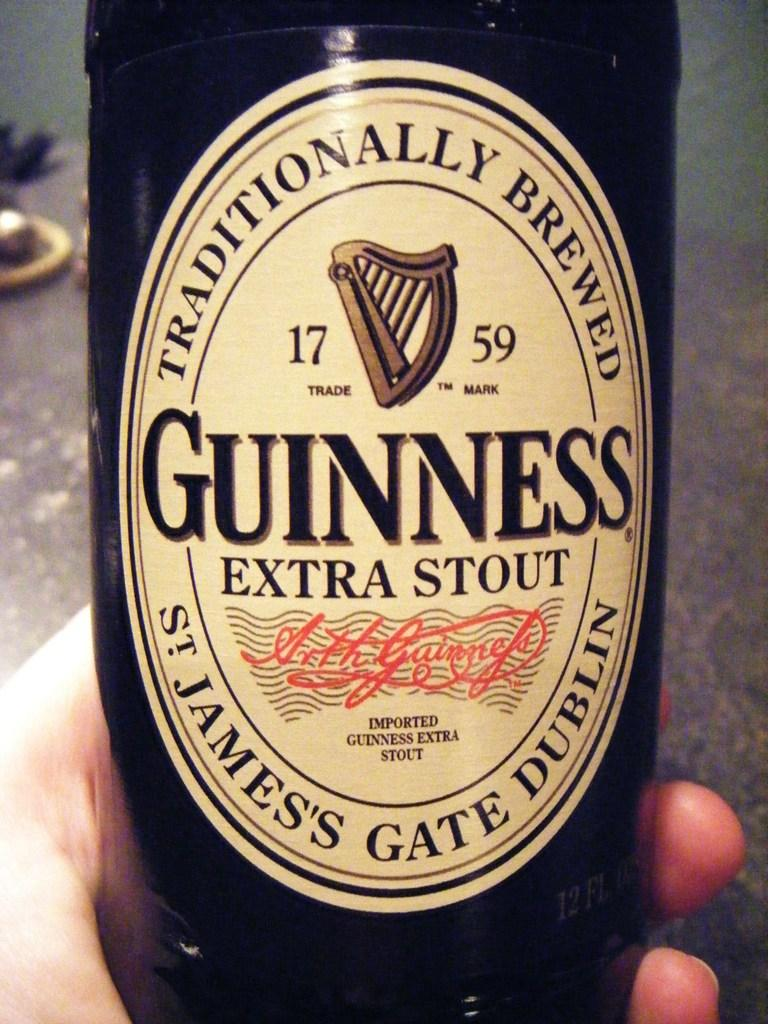Who is present in the image? There is a person in the image. What is the person holding in the image? The person is holding a wine bottle. What can be said about the color of the wine bottle? The wine bottle is black in color. Is there any text or writing on the wine bottle? Yes, there is writing on the wine bottle. What invention is the person using to open the wine bottle in the image? There is no invention or tool visible in the image that is being used to open the wine bottle. 